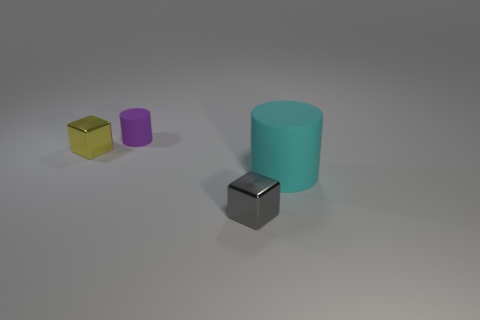Add 1 tiny things. How many objects exist? 5 Subtract all green rubber objects. Subtract all small yellow metal cubes. How many objects are left? 3 Add 3 rubber cylinders. How many rubber cylinders are left? 5 Add 4 big cyan cylinders. How many big cyan cylinders exist? 5 Subtract 0 cyan blocks. How many objects are left? 4 